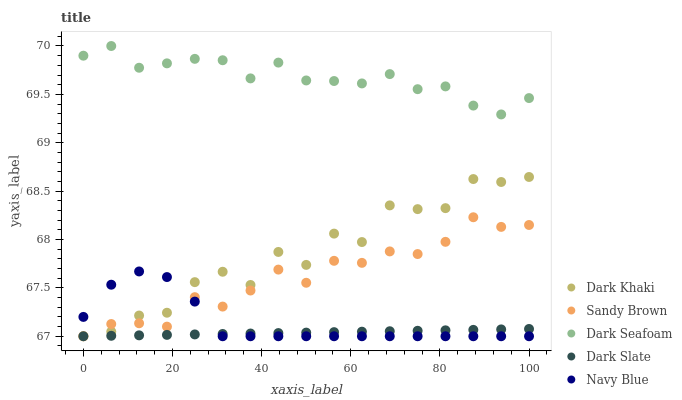Does Dark Slate have the minimum area under the curve?
Answer yes or no. Yes. Does Dark Seafoam have the maximum area under the curve?
Answer yes or no. Yes. Does Dark Seafoam have the minimum area under the curve?
Answer yes or no. No. Does Dark Slate have the maximum area under the curve?
Answer yes or no. No. Is Dark Slate the smoothest?
Answer yes or no. Yes. Is Dark Khaki the roughest?
Answer yes or no. Yes. Is Dark Seafoam the smoothest?
Answer yes or no. No. Is Dark Seafoam the roughest?
Answer yes or no. No. Does Dark Khaki have the lowest value?
Answer yes or no. Yes. Does Dark Seafoam have the lowest value?
Answer yes or no. No. Does Dark Seafoam have the highest value?
Answer yes or no. Yes. Does Dark Slate have the highest value?
Answer yes or no. No. Is Navy Blue less than Dark Seafoam?
Answer yes or no. Yes. Is Dark Seafoam greater than Dark Khaki?
Answer yes or no. Yes. Does Dark Khaki intersect Dark Slate?
Answer yes or no. Yes. Is Dark Khaki less than Dark Slate?
Answer yes or no. No. Is Dark Khaki greater than Dark Slate?
Answer yes or no. No. Does Navy Blue intersect Dark Seafoam?
Answer yes or no. No. 